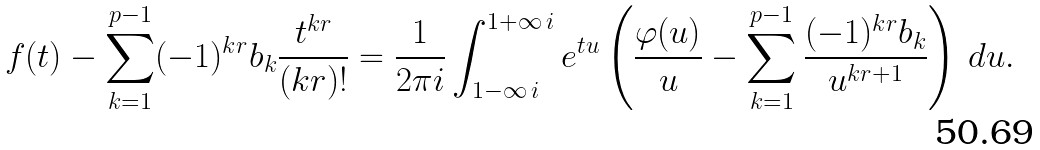Convert formula to latex. <formula><loc_0><loc_0><loc_500><loc_500>f ( t ) - \sum _ { k = 1 } ^ { p - 1 } ( - 1 ) ^ { k r } b _ { k } \frac { t ^ { k r } } { ( k r ) ! } = \frac { 1 } { 2 \pi i } \int _ { 1 - \infty \, i } ^ { 1 + \infty \, i } e ^ { t u } \left ( \frac { \varphi ( u ) } { u } - \sum _ { k = 1 } ^ { p - 1 } \frac { ( - 1 ) ^ { k r } b _ { k } } { u ^ { k r + 1 } } \right ) \, d u .</formula> 